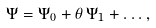<formula> <loc_0><loc_0><loc_500><loc_500>\Psi = \Psi _ { 0 } + \theta \, \Psi _ { 1 } + \dots ,</formula> 